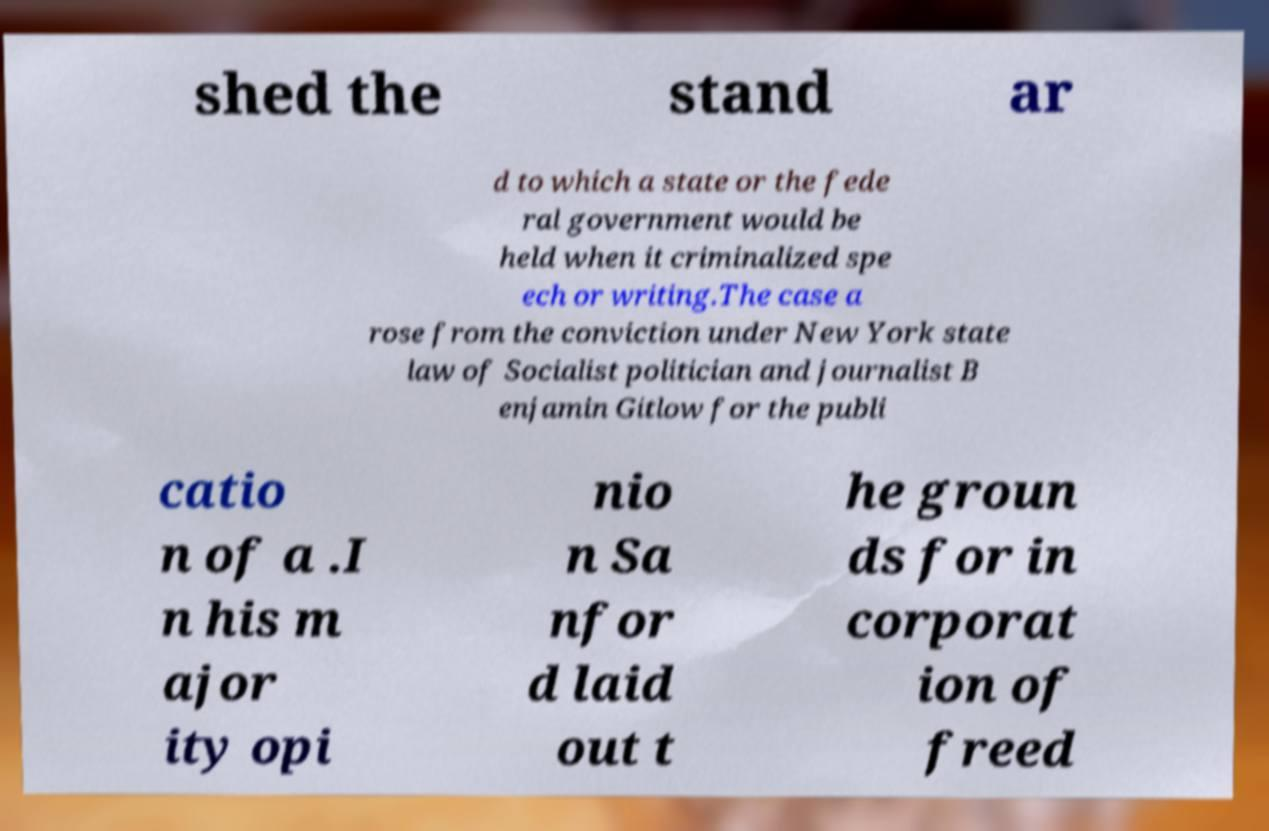Please read and relay the text visible in this image. What does it say? shed the stand ar d to which a state or the fede ral government would be held when it criminalized spe ech or writing.The case a rose from the conviction under New York state law of Socialist politician and journalist B enjamin Gitlow for the publi catio n of a .I n his m ajor ity opi nio n Sa nfor d laid out t he groun ds for in corporat ion of freed 